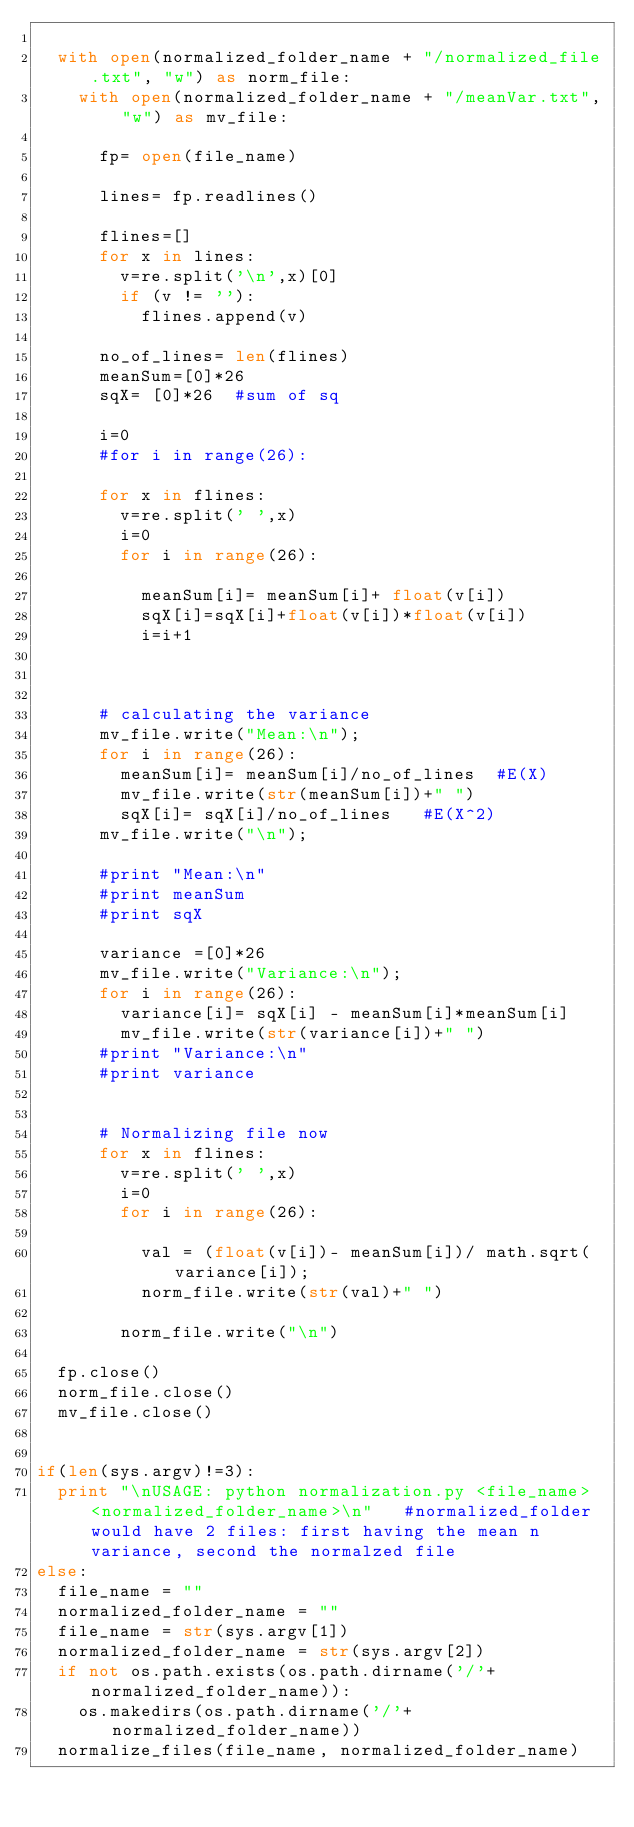Convert code to text. <code><loc_0><loc_0><loc_500><loc_500><_Python_>	
	with open(normalized_folder_name + "/normalized_file.txt", "w") as norm_file:	
		with open(normalized_folder_name + "/meanVar.txt", "w") as mv_file:
			
			fp= open(file_name)   

			lines= fp.readlines()

			flines=[]
			for x in lines:
				v=re.split('\n',x)[0]
				if (v != ''):
					flines.append(v)	
					
			no_of_lines= len(flines)
			meanSum=[0]*26
			sqX= [0]*26  #sum of sq

			i=0
			#for i in range(26):

			for x in flines: 
				v=re.split(' ',x)
				i=0
				for i in range(26):
					
					meanSum[i]= meanSum[i]+ float(v[i])
					sqX[i]=sqX[i]+float(v[i])*float(v[i])
					i=i+1
						
				
			
			# calculating the variance
			mv_file.write("Mean:\n");
			for i in range(26):
				meanSum[i]= meanSum[i]/no_of_lines  #E(X)
				mv_file.write(str(meanSum[i])+" ")
				sqX[i]= sqX[i]/no_of_lines   #E(X^2)
			mv_file.write("\n");

			#print "Mean:\n"
			#print meanSum
			#print sqX

			variance =[0]*26
			mv_file.write("Variance:\n");
			for i in range(26):
				variance[i]= sqX[i] - meanSum[i]*meanSum[i]
				mv_file.write(str(variance[i])+" ")
			#print "Variance:\n"
			#print variance


			# Normalizing file now
			for x in flines: 
				v=re.split(' ',x)
				i=0
				for i in range(26):
					
					val = (float(v[i])- meanSum[i])/ math.sqrt(variance[i]);
					norm_file.write(str(val)+" ")
					
				norm_file.write("\n")

	fp.close()
	norm_file.close()
	mv_file.close()
				

if(len(sys.argv)!=3):
	print "\nUSAGE: python normalization.py <file_name> <normalized_folder_name>\n"   #normalized_folder would have 2 files: first having the mean n variance, second the normalzed file
else:
	file_name = ""
	normalized_folder_name = ""
	file_name = str(sys.argv[1])
	normalized_folder_name = str(sys.argv[2])
	if not os.path.exists(os.path.dirname('/'+ normalized_folder_name)):
		os.makedirs(os.path.dirname('/'+normalized_folder_name))
	normalize_files(file_name, normalized_folder_name)
</code> 